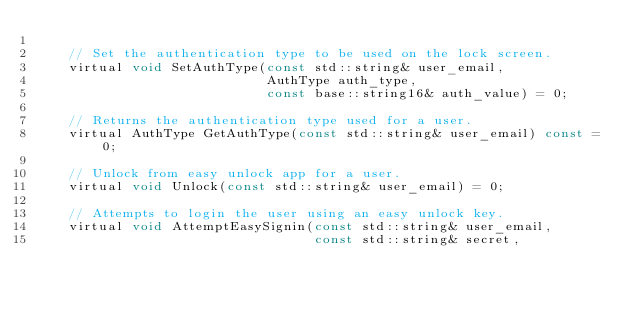<code> <loc_0><loc_0><loc_500><loc_500><_C_>
    // Set the authentication type to be used on the lock screen.
    virtual void SetAuthType(const std::string& user_email,
                             AuthType auth_type,
                             const base::string16& auth_value) = 0;

    // Returns the authentication type used for a user.
    virtual AuthType GetAuthType(const std::string& user_email) const = 0;

    // Unlock from easy unlock app for a user.
    virtual void Unlock(const std::string& user_email) = 0;

    // Attempts to login the user using an easy unlock key.
    virtual void AttemptEasySignin(const std::string& user_email,
                                   const std::string& secret,</code> 